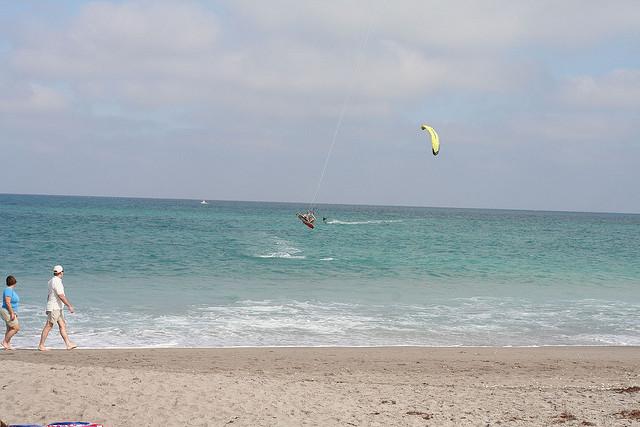Is there a person flying in this photo?
Keep it brief. No. How many people are walking on the beach?
Keep it brief. 2. Is that a park?
Give a very brief answer. No. Is the man surfing?
Be succinct. Yes. Are there any people on the beach?
Give a very brief answer. Yes. Are there any people in the water?
Short answer required. Yes. How many people are in this picture?
Keep it brief. 3. Is it a cloudy day?
Give a very brief answer. Yes. Do they have on wetsuits?
Write a very short answer. No. What is in the sky?
Concise answer only. Kite. How many people are flying kites?
Concise answer only. 2. Which of the man's arms is slightly higher?
Concise answer only. Right. Is there grass growing in the sand?
Be succinct. No. How many people are on the beach?
Short answer required. 2. 